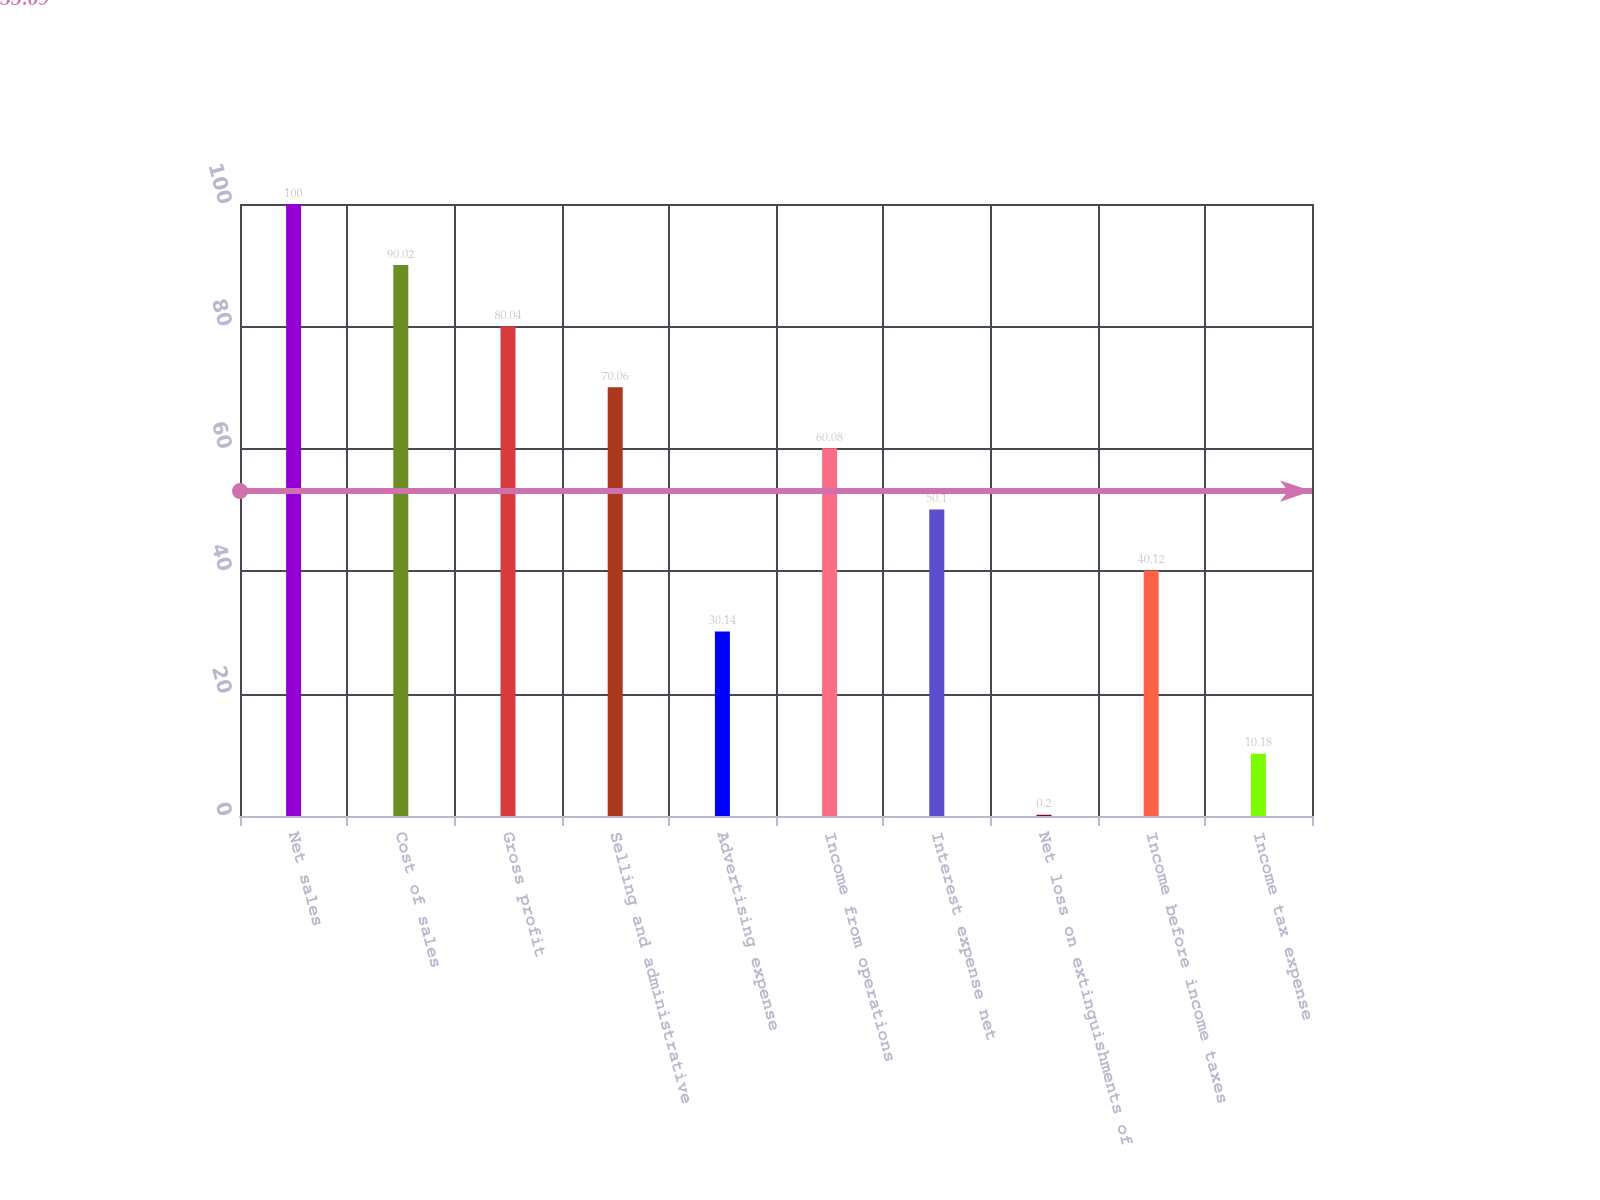Convert chart to OTSL. <chart><loc_0><loc_0><loc_500><loc_500><bar_chart><fcel>Net sales<fcel>Cost of sales<fcel>Gross profit<fcel>Selling and administrative<fcel>Advertising expense<fcel>Income from operations<fcel>Interest expense net<fcel>Net loss on extinguishments of<fcel>Income before income taxes<fcel>Income tax expense<nl><fcel>100<fcel>90.02<fcel>80.04<fcel>70.06<fcel>30.14<fcel>60.08<fcel>50.1<fcel>0.2<fcel>40.12<fcel>10.18<nl></chart> 